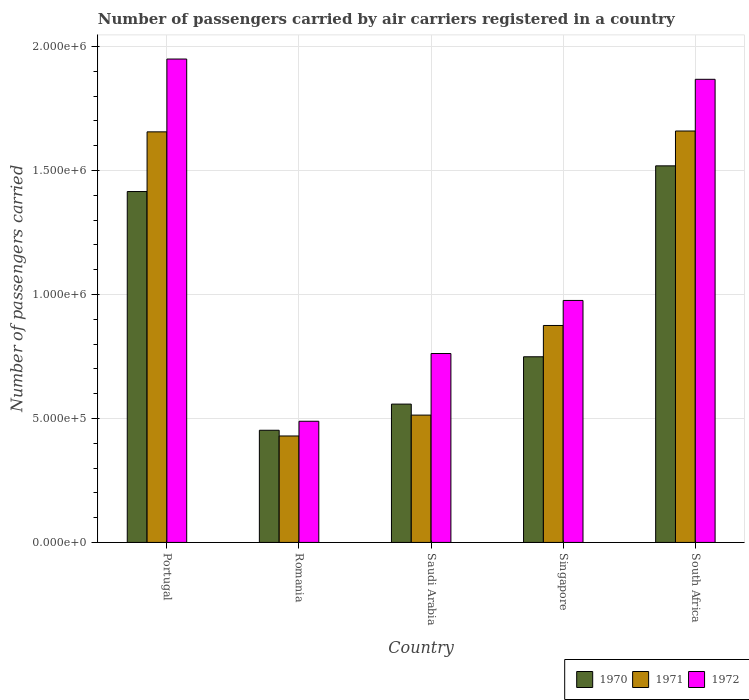How many different coloured bars are there?
Make the answer very short. 3. Are the number of bars per tick equal to the number of legend labels?
Provide a short and direct response. Yes. Are the number of bars on each tick of the X-axis equal?
Make the answer very short. Yes. How many bars are there on the 2nd tick from the left?
Ensure brevity in your answer.  3. What is the label of the 4th group of bars from the left?
Your answer should be compact. Singapore. In how many cases, is the number of bars for a given country not equal to the number of legend labels?
Your answer should be very brief. 0. What is the number of passengers carried by air carriers in 1972 in Saudi Arabia?
Give a very brief answer. 7.62e+05. Across all countries, what is the maximum number of passengers carried by air carriers in 1970?
Offer a very short reply. 1.52e+06. Across all countries, what is the minimum number of passengers carried by air carriers in 1970?
Offer a very short reply. 4.52e+05. In which country was the number of passengers carried by air carriers in 1972 maximum?
Offer a very short reply. Portugal. In which country was the number of passengers carried by air carriers in 1972 minimum?
Your response must be concise. Romania. What is the total number of passengers carried by air carriers in 1970 in the graph?
Your answer should be compact. 4.69e+06. What is the difference between the number of passengers carried by air carriers in 1971 in Romania and that in Singapore?
Your response must be concise. -4.46e+05. What is the difference between the number of passengers carried by air carriers in 1972 in Singapore and the number of passengers carried by air carriers in 1970 in Saudi Arabia?
Your answer should be compact. 4.18e+05. What is the average number of passengers carried by air carriers in 1970 per country?
Your answer should be compact. 9.39e+05. What is the difference between the number of passengers carried by air carriers of/in 1972 and number of passengers carried by air carriers of/in 1970 in South Africa?
Offer a terse response. 3.49e+05. What is the ratio of the number of passengers carried by air carriers in 1971 in Portugal to that in South Africa?
Give a very brief answer. 1. What is the difference between the highest and the second highest number of passengers carried by air carriers in 1972?
Keep it short and to the point. 8.17e+04. What is the difference between the highest and the lowest number of passengers carried by air carriers in 1971?
Offer a terse response. 1.23e+06. Is the sum of the number of passengers carried by air carriers in 1972 in Portugal and Romania greater than the maximum number of passengers carried by air carriers in 1971 across all countries?
Keep it short and to the point. Yes. Is it the case that in every country, the sum of the number of passengers carried by air carriers in 1972 and number of passengers carried by air carriers in 1971 is greater than the number of passengers carried by air carriers in 1970?
Give a very brief answer. Yes. How many bars are there?
Provide a short and direct response. 15. Are the values on the major ticks of Y-axis written in scientific E-notation?
Offer a very short reply. Yes. How are the legend labels stacked?
Provide a succinct answer. Horizontal. What is the title of the graph?
Keep it short and to the point. Number of passengers carried by air carriers registered in a country. What is the label or title of the Y-axis?
Your response must be concise. Number of passengers carried. What is the Number of passengers carried of 1970 in Portugal?
Your response must be concise. 1.42e+06. What is the Number of passengers carried of 1971 in Portugal?
Your answer should be very brief. 1.66e+06. What is the Number of passengers carried of 1972 in Portugal?
Provide a succinct answer. 1.95e+06. What is the Number of passengers carried of 1970 in Romania?
Offer a very short reply. 4.52e+05. What is the Number of passengers carried in 1971 in Romania?
Offer a very short reply. 4.29e+05. What is the Number of passengers carried of 1972 in Romania?
Your response must be concise. 4.89e+05. What is the Number of passengers carried in 1970 in Saudi Arabia?
Your answer should be compact. 5.58e+05. What is the Number of passengers carried in 1971 in Saudi Arabia?
Offer a very short reply. 5.14e+05. What is the Number of passengers carried of 1972 in Saudi Arabia?
Provide a succinct answer. 7.62e+05. What is the Number of passengers carried in 1970 in Singapore?
Make the answer very short. 7.49e+05. What is the Number of passengers carried in 1971 in Singapore?
Offer a terse response. 8.75e+05. What is the Number of passengers carried in 1972 in Singapore?
Your response must be concise. 9.76e+05. What is the Number of passengers carried in 1970 in South Africa?
Make the answer very short. 1.52e+06. What is the Number of passengers carried of 1971 in South Africa?
Keep it short and to the point. 1.66e+06. What is the Number of passengers carried of 1972 in South Africa?
Provide a succinct answer. 1.87e+06. Across all countries, what is the maximum Number of passengers carried in 1970?
Offer a very short reply. 1.52e+06. Across all countries, what is the maximum Number of passengers carried of 1971?
Provide a short and direct response. 1.66e+06. Across all countries, what is the maximum Number of passengers carried of 1972?
Your answer should be very brief. 1.95e+06. Across all countries, what is the minimum Number of passengers carried in 1970?
Your answer should be compact. 4.52e+05. Across all countries, what is the minimum Number of passengers carried in 1971?
Offer a terse response. 4.29e+05. Across all countries, what is the minimum Number of passengers carried in 1972?
Your answer should be very brief. 4.89e+05. What is the total Number of passengers carried of 1970 in the graph?
Provide a short and direct response. 4.69e+06. What is the total Number of passengers carried of 1971 in the graph?
Your answer should be very brief. 5.13e+06. What is the total Number of passengers carried of 1972 in the graph?
Your answer should be very brief. 6.04e+06. What is the difference between the Number of passengers carried in 1970 in Portugal and that in Romania?
Provide a short and direct response. 9.63e+05. What is the difference between the Number of passengers carried of 1971 in Portugal and that in Romania?
Offer a terse response. 1.23e+06. What is the difference between the Number of passengers carried in 1972 in Portugal and that in Romania?
Keep it short and to the point. 1.46e+06. What is the difference between the Number of passengers carried of 1970 in Portugal and that in Saudi Arabia?
Give a very brief answer. 8.57e+05. What is the difference between the Number of passengers carried in 1971 in Portugal and that in Saudi Arabia?
Offer a terse response. 1.14e+06. What is the difference between the Number of passengers carried in 1972 in Portugal and that in Saudi Arabia?
Provide a short and direct response. 1.19e+06. What is the difference between the Number of passengers carried in 1970 in Portugal and that in Singapore?
Give a very brief answer. 6.66e+05. What is the difference between the Number of passengers carried in 1971 in Portugal and that in Singapore?
Make the answer very short. 7.81e+05. What is the difference between the Number of passengers carried in 1972 in Portugal and that in Singapore?
Give a very brief answer. 9.74e+05. What is the difference between the Number of passengers carried in 1970 in Portugal and that in South Africa?
Offer a very short reply. -1.04e+05. What is the difference between the Number of passengers carried of 1971 in Portugal and that in South Africa?
Make the answer very short. -3400. What is the difference between the Number of passengers carried in 1972 in Portugal and that in South Africa?
Make the answer very short. 8.17e+04. What is the difference between the Number of passengers carried in 1970 in Romania and that in Saudi Arabia?
Give a very brief answer. -1.06e+05. What is the difference between the Number of passengers carried in 1971 in Romania and that in Saudi Arabia?
Ensure brevity in your answer.  -8.42e+04. What is the difference between the Number of passengers carried of 1972 in Romania and that in Saudi Arabia?
Provide a short and direct response. -2.73e+05. What is the difference between the Number of passengers carried in 1970 in Romania and that in Singapore?
Offer a very short reply. -2.96e+05. What is the difference between the Number of passengers carried in 1971 in Romania and that in Singapore?
Offer a terse response. -4.46e+05. What is the difference between the Number of passengers carried of 1972 in Romania and that in Singapore?
Offer a terse response. -4.87e+05. What is the difference between the Number of passengers carried of 1970 in Romania and that in South Africa?
Give a very brief answer. -1.07e+06. What is the difference between the Number of passengers carried of 1971 in Romania and that in South Africa?
Give a very brief answer. -1.23e+06. What is the difference between the Number of passengers carried in 1972 in Romania and that in South Africa?
Your answer should be very brief. -1.38e+06. What is the difference between the Number of passengers carried in 1970 in Saudi Arabia and that in Singapore?
Your response must be concise. -1.91e+05. What is the difference between the Number of passengers carried in 1971 in Saudi Arabia and that in Singapore?
Provide a succinct answer. -3.62e+05. What is the difference between the Number of passengers carried of 1972 in Saudi Arabia and that in Singapore?
Give a very brief answer. -2.14e+05. What is the difference between the Number of passengers carried in 1970 in Saudi Arabia and that in South Africa?
Offer a terse response. -9.61e+05. What is the difference between the Number of passengers carried in 1971 in Saudi Arabia and that in South Africa?
Keep it short and to the point. -1.15e+06. What is the difference between the Number of passengers carried of 1972 in Saudi Arabia and that in South Africa?
Your answer should be very brief. -1.11e+06. What is the difference between the Number of passengers carried in 1970 in Singapore and that in South Africa?
Offer a terse response. -7.70e+05. What is the difference between the Number of passengers carried in 1971 in Singapore and that in South Africa?
Give a very brief answer. -7.84e+05. What is the difference between the Number of passengers carried of 1972 in Singapore and that in South Africa?
Offer a very short reply. -8.92e+05. What is the difference between the Number of passengers carried in 1970 in Portugal and the Number of passengers carried in 1971 in Romania?
Provide a succinct answer. 9.86e+05. What is the difference between the Number of passengers carried in 1970 in Portugal and the Number of passengers carried in 1972 in Romania?
Provide a short and direct response. 9.27e+05. What is the difference between the Number of passengers carried in 1971 in Portugal and the Number of passengers carried in 1972 in Romania?
Offer a terse response. 1.17e+06. What is the difference between the Number of passengers carried in 1970 in Portugal and the Number of passengers carried in 1971 in Saudi Arabia?
Your answer should be very brief. 9.02e+05. What is the difference between the Number of passengers carried in 1970 in Portugal and the Number of passengers carried in 1972 in Saudi Arabia?
Provide a succinct answer. 6.53e+05. What is the difference between the Number of passengers carried of 1971 in Portugal and the Number of passengers carried of 1972 in Saudi Arabia?
Keep it short and to the point. 8.94e+05. What is the difference between the Number of passengers carried in 1970 in Portugal and the Number of passengers carried in 1971 in Singapore?
Offer a terse response. 5.40e+05. What is the difference between the Number of passengers carried in 1970 in Portugal and the Number of passengers carried in 1972 in Singapore?
Provide a short and direct response. 4.39e+05. What is the difference between the Number of passengers carried in 1971 in Portugal and the Number of passengers carried in 1972 in Singapore?
Your answer should be compact. 6.80e+05. What is the difference between the Number of passengers carried of 1970 in Portugal and the Number of passengers carried of 1971 in South Africa?
Your answer should be compact. -2.44e+05. What is the difference between the Number of passengers carried of 1970 in Portugal and the Number of passengers carried of 1972 in South Africa?
Keep it short and to the point. -4.53e+05. What is the difference between the Number of passengers carried in 1971 in Portugal and the Number of passengers carried in 1972 in South Africa?
Ensure brevity in your answer.  -2.12e+05. What is the difference between the Number of passengers carried of 1970 in Romania and the Number of passengers carried of 1971 in Saudi Arabia?
Your response must be concise. -6.11e+04. What is the difference between the Number of passengers carried in 1970 in Romania and the Number of passengers carried in 1972 in Saudi Arabia?
Make the answer very short. -3.10e+05. What is the difference between the Number of passengers carried of 1971 in Romania and the Number of passengers carried of 1972 in Saudi Arabia?
Keep it short and to the point. -3.33e+05. What is the difference between the Number of passengers carried in 1970 in Romania and the Number of passengers carried in 1971 in Singapore?
Provide a short and direct response. -4.23e+05. What is the difference between the Number of passengers carried of 1970 in Romania and the Number of passengers carried of 1972 in Singapore?
Keep it short and to the point. -5.24e+05. What is the difference between the Number of passengers carried of 1971 in Romania and the Number of passengers carried of 1972 in Singapore?
Provide a short and direct response. -5.47e+05. What is the difference between the Number of passengers carried in 1970 in Romania and the Number of passengers carried in 1971 in South Africa?
Keep it short and to the point. -1.21e+06. What is the difference between the Number of passengers carried in 1970 in Romania and the Number of passengers carried in 1972 in South Africa?
Give a very brief answer. -1.42e+06. What is the difference between the Number of passengers carried of 1971 in Romania and the Number of passengers carried of 1972 in South Africa?
Provide a succinct answer. -1.44e+06. What is the difference between the Number of passengers carried of 1970 in Saudi Arabia and the Number of passengers carried of 1971 in Singapore?
Provide a succinct answer. -3.17e+05. What is the difference between the Number of passengers carried in 1970 in Saudi Arabia and the Number of passengers carried in 1972 in Singapore?
Provide a short and direct response. -4.18e+05. What is the difference between the Number of passengers carried in 1971 in Saudi Arabia and the Number of passengers carried in 1972 in Singapore?
Your response must be concise. -4.62e+05. What is the difference between the Number of passengers carried in 1970 in Saudi Arabia and the Number of passengers carried in 1971 in South Africa?
Your answer should be compact. -1.10e+06. What is the difference between the Number of passengers carried of 1970 in Saudi Arabia and the Number of passengers carried of 1972 in South Africa?
Offer a terse response. -1.31e+06. What is the difference between the Number of passengers carried of 1971 in Saudi Arabia and the Number of passengers carried of 1972 in South Africa?
Give a very brief answer. -1.35e+06. What is the difference between the Number of passengers carried in 1970 in Singapore and the Number of passengers carried in 1971 in South Africa?
Ensure brevity in your answer.  -9.11e+05. What is the difference between the Number of passengers carried of 1970 in Singapore and the Number of passengers carried of 1972 in South Africa?
Your answer should be very brief. -1.12e+06. What is the difference between the Number of passengers carried of 1971 in Singapore and the Number of passengers carried of 1972 in South Africa?
Make the answer very short. -9.93e+05. What is the average Number of passengers carried in 1970 per country?
Provide a succinct answer. 9.39e+05. What is the average Number of passengers carried of 1971 per country?
Ensure brevity in your answer.  1.03e+06. What is the average Number of passengers carried of 1972 per country?
Provide a succinct answer. 1.21e+06. What is the difference between the Number of passengers carried in 1970 and Number of passengers carried in 1971 in Portugal?
Your answer should be compact. -2.41e+05. What is the difference between the Number of passengers carried in 1970 and Number of passengers carried in 1972 in Portugal?
Give a very brief answer. -5.34e+05. What is the difference between the Number of passengers carried of 1971 and Number of passengers carried of 1972 in Portugal?
Your answer should be very brief. -2.94e+05. What is the difference between the Number of passengers carried of 1970 and Number of passengers carried of 1971 in Romania?
Offer a terse response. 2.31e+04. What is the difference between the Number of passengers carried in 1970 and Number of passengers carried in 1972 in Romania?
Make the answer very short. -3.63e+04. What is the difference between the Number of passengers carried of 1971 and Number of passengers carried of 1972 in Romania?
Your answer should be very brief. -5.94e+04. What is the difference between the Number of passengers carried of 1970 and Number of passengers carried of 1971 in Saudi Arabia?
Ensure brevity in your answer.  4.44e+04. What is the difference between the Number of passengers carried in 1970 and Number of passengers carried in 1972 in Saudi Arabia?
Make the answer very short. -2.04e+05. What is the difference between the Number of passengers carried in 1971 and Number of passengers carried in 1972 in Saudi Arabia?
Provide a short and direct response. -2.48e+05. What is the difference between the Number of passengers carried of 1970 and Number of passengers carried of 1971 in Singapore?
Your answer should be very brief. -1.26e+05. What is the difference between the Number of passengers carried in 1970 and Number of passengers carried in 1972 in Singapore?
Offer a terse response. -2.27e+05. What is the difference between the Number of passengers carried of 1971 and Number of passengers carried of 1972 in Singapore?
Ensure brevity in your answer.  -1.01e+05. What is the difference between the Number of passengers carried of 1970 and Number of passengers carried of 1971 in South Africa?
Your answer should be compact. -1.40e+05. What is the difference between the Number of passengers carried of 1970 and Number of passengers carried of 1972 in South Africa?
Keep it short and to the point. -3.49e+05. What is the difference between the Number of passengers carried in 1971 and Number of passengers carried in 1972 in South Africa?
Provide a short and direct response. -2.09e+05. What is the ratio of the Number of passengers carried of 1970 in Portugal to that in Romania?
Give a very brief answer. 3.13. What is the ratio of the Number of passengers carried of 1971 in Portugal to that in Romania?
Offer a terse response. 3.86. What is the ratio of the Number of passengers carried of 1972 in Portugal to that in Romania?
Your answer should be compact. 3.99. What is the ratio of the Number of passengers carried of 1970 in Portugal to that in Saudi Arabia?
Provide a short and direct response. 2.54. What is the ratio of the Number of passengers carried in 1971 in Portugal to that in Saudi Arabia?
Offer a terse response. 3.22. What is the ratio of the Number of passengers carried in 1972 in Portugal to that in Saudi Arabia?
Offer a very short reply. 2.56. What is the ratio of the Number of passengers carried in 1970 in Portugal to that in Singapore?
Your answer should be compact. 1.89. What is the ratio of the Number of passengers carried of 1971 in Portugal to that in Singapore?
Offer a terse response. 1.89. What is the ratio of the Number of passengers carried in 1972 in Portugal to that in Singapore?
Keep it short and to the point. 2. What is the ratio of the Number of passengers carried in 1970 in Portugal to that in South Africa?
Provide a short and direct response. 0.93. What is the ratio of the Number of passengers carried of 1971 in Portugal to that in South Africa?
Offer a very short reply. 1. What is the ratio of the Number of passengers carried of 1972 in Portugal to that in South Africa?
Provide a succinct answer. 1.04. What is the ratio of the Number of passengers carried in 1970 in Romania to that in Saudi Arabia?
Provide a short and direct response. 0.81. What is the ratio of the Number of passengers carried of 1971 in Romania to that in Saudi Arabia?
Ensure brevity in your answer.  0.84. What is the ratio of the Number of passengers carried in 1972 in Romania to that in Saudi Arabia?
Provide a succinct answer. 0.64. What is the ratio of the Number of passengers carried in 1970 in Romania to that in Singapore?
Your answer should be very brief. 0.6. What is the ratio of the Number of passengers carried of 1971 in Romania to that in Singapore?
Your answer should be compact. 0.49. What is the ratio of the Number of passengers carried in 1972 in Romania to that in Singapore?
Keep it short and to the point. 0.5. What is the ratio of the Number of passengers carried in 1970 in Romania to that in South Africa?
Offer a terse response. 0.3. What is the ratio of the Number of passengers carried in 1971 in Romania to that in South Africa?
Ensure brevity in your answer.  0.26. What is the ratio of the Number of passengers carried of 1972 in Romania to that in South Africa?
Your answer should be very brief. 0.26. What is the ratio of the Number of passengers carried of 1970 in Saudi Arabia to that in Singapore?
Your answer should be very brief. 0.75. What is the ratio of the Number of passengers carried of 1971 in Saudi Arabia to that in Singapore?
Your answer should be compact. 0.59. What is the ratio of the Number of passengers carried of 1972 in Saudi Arabia to that in Singapore?
Keep it short and to the point. 0.78. What is the ratio of the Number of passengers carried of 1970 in Saudi Arabia to that in South Africa?
Your response must be concise. 0.37. What is the ratio of the Number of passengers carried in 1971 in Saudi Arabia to that in South Africa?
Provide a succinct answer. 0.31. What is the ratio of the Number of passengers carried of 1972 in Saudi Arabia to that in South Africa?
Your answer should be compact. 0.41. What is the ratio of the Number of passengers carried of 1970 in Singapore to that in South Africa?
Make the answer very short. 0.49. What is the ratio of the Number of passengers carried of 1971 in Singapore to that in South Africa?
Your answer should be compact. 0.53. What is the ratio of the Number of passengers carried in 1972 in Singapore to that in South Africa?
Your answer should be very brief. 0.52. What is the difference between the highest and the second highest Number of passengers carried in 1970?
Your response must be concise. 1.04e+05. What is the difference between the highest and the second highest Number of passengers carried in 1971?
Your response must be concise. 3400. What is the difference between the highest and the second highest Number of passengers carried of 1972?
Give a very brief answer. 8.17e+04. What is the difference between the highest and the lowest Number of passengers carried in 1970?
Ensure brevity in your answer.  1.07e+06. What is the difference between the highest and the lowest Number of passengers carried of 1971?
Make the answer very short. 1.23e+06. What is the difference between the highest and the lowest Number of passengers carried in 1972?
Your answer should be very brief. 1.46e+06. 